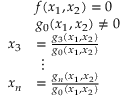<formula> <loc_0><loc_0><loc_500><loc_500>{ \begin{array} { r l } & { f ( x _ { 1 } , x _ { 2 } ) = 0 } \\ & { g _ { 0 } ( x _ { 1 } , x _ { 2 } ) \neq 0 } \\ { x _ { 3 } } & { = { \frac { g _ { 3 } ( x _ { 1 } , x _ { 2 } ) } { g _ { 0 } ( x _ { 1 } , x _ { 2 } ) } } } \\ & { \ \vdots } \\ { x _ { n } } & { = { \frac { g _ { n } ( x _ { 1 } , x _ { 2 } ) } { g _ { 0 } ( x _ { 1 } , x _ { 2 } ) } } } \end{array} }</formula> 